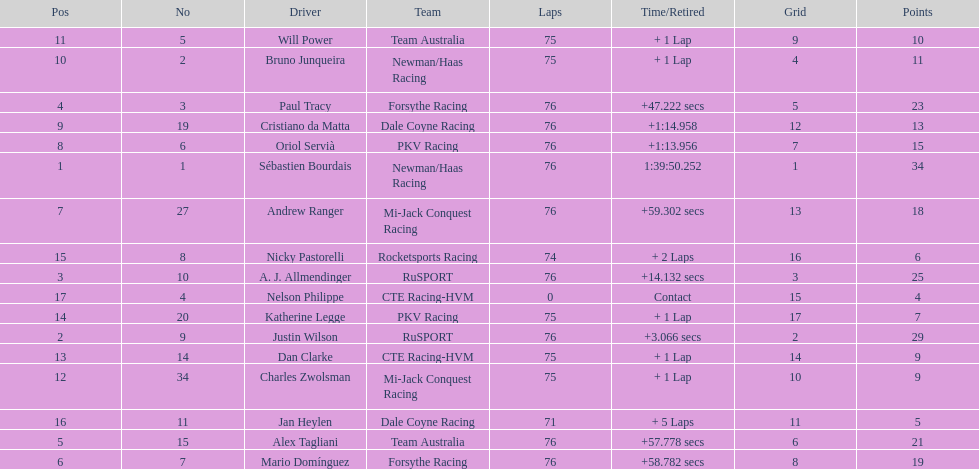Charles zwolsman acquired the same number of points as who? Dan Clarke. Parse the table in full. {'header': ['Pos', 'No', 'Driver', 'Team', 'Laps', 'Time/Retired', 'Grid', 'Points'], 'rows': [['11', '5', 'Will Power', 'Team Australia', '75', '+ 1 Lap', '9', '10'], ['10', '2', 'Bruno Junqueira', 'Newman/Haas Racing', '75', '+ 1 Lap', '4', '11'], ['4', '3', 'Paul Tracy', 'Forsythe Racing', '76', '+47.222 secs', '5', '23'], ['9', '19', 'Cristiano da Matta', 'Dale Coyne Racing', '76', '+1:14.958', '12', '13'], ['8', '6', 'Oriol Servià', 'PKV Racing', '76', '+1:13.956', '7', '15'], ['1', '1', 'Sébastien Bourdais', 'Newman/Haas Racing', '76', '1:39:50.252', '1', '34'], ['7', '27', 'Andrew Ranger', 'Mi-Jack Conquest Racing', '76', '+59.302 secs', '13', '18'], ['15', '8', 'Nicky Pastorelli', 'Rocketsports Racing', '74', '+ 2 Laps', '16', '6'], ['3', '10', 'A. J. Allmendinger', 'RuSPORT', '76', '+14.132 secs', '3', '25'], ['17', '4', 'Nelson Philippe', 'CTE Racing-HVM', '0', 'Contact', '15', '4'], ['14', '20', 'Katherine Legge', 'PKV Racing', '75', '+ 1 Lap', '17', '7'], ['2', '9', 'Justin Wilson', 'RuSPORT', '76', '+3.066 secs', '2', '29'], ['13', '14', 'Dan Clarke', 'CTE Racing-HVM', '75', '+ 1 Lap', '14', '9'], ['12', '34', 'Charles Zwolsman', 'Mi-Jack Conquest Racing', '75', '+ 1 Lap', '10', '9'], ['16', '11', 'Jan Heylen', 'Dale Coyne Racing', '71', '+ 5 Laps', '11', '5'], ['5', '15', 'Alex Tagliani', 'Team Australia', '76', '+57.778 secs', '6', '21'], ['6', '7', 'Mario Domínguez', 'Forsythe Racing', '76', '+58.782 secs', '8', '19']]} 